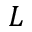Convert formula to latex. <formula><loc_0><loc_0><loc_500><loc_500>L</formula> 